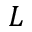Convert formula to latex. <formula><loc_0><loc_0><loc_500><loc_500>L</formula> 